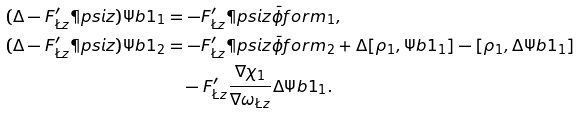Convert formula to latex. <formula><loc_0><loc_0><loc_500><loc_500>( \Delta - F ^ { \prime } _ { \L z } \P p s i z ) \Psi b 1 _ { 1 } & = - F ^ { \prime } _ { \L z } \P p s i z \bar { \phi } f o r m _ { 1 } , \\ ( \Delta - F ^ { \prime } _ { \L z } \P p s i z ) \Psi b 1 _ { 2 } & = - F ^ { \prime } _ { \L z } \P p s i z \bar { \phi } f o r m _ { 2 } + \Delta [ \rho _ { 1 } , \Psi b 1 _ { 1 } ] - [ \rho _ { 1 } , \Delta \Psi b 1 _ { 1 } ] \\ & \quad - F ^ { \prime } _ { \L z } \frac { \nabla \chi _ { 1 } } { \nabla \omega _ { \L z } } \Delta \Psi b 1 _ { 1 } .</formula> 